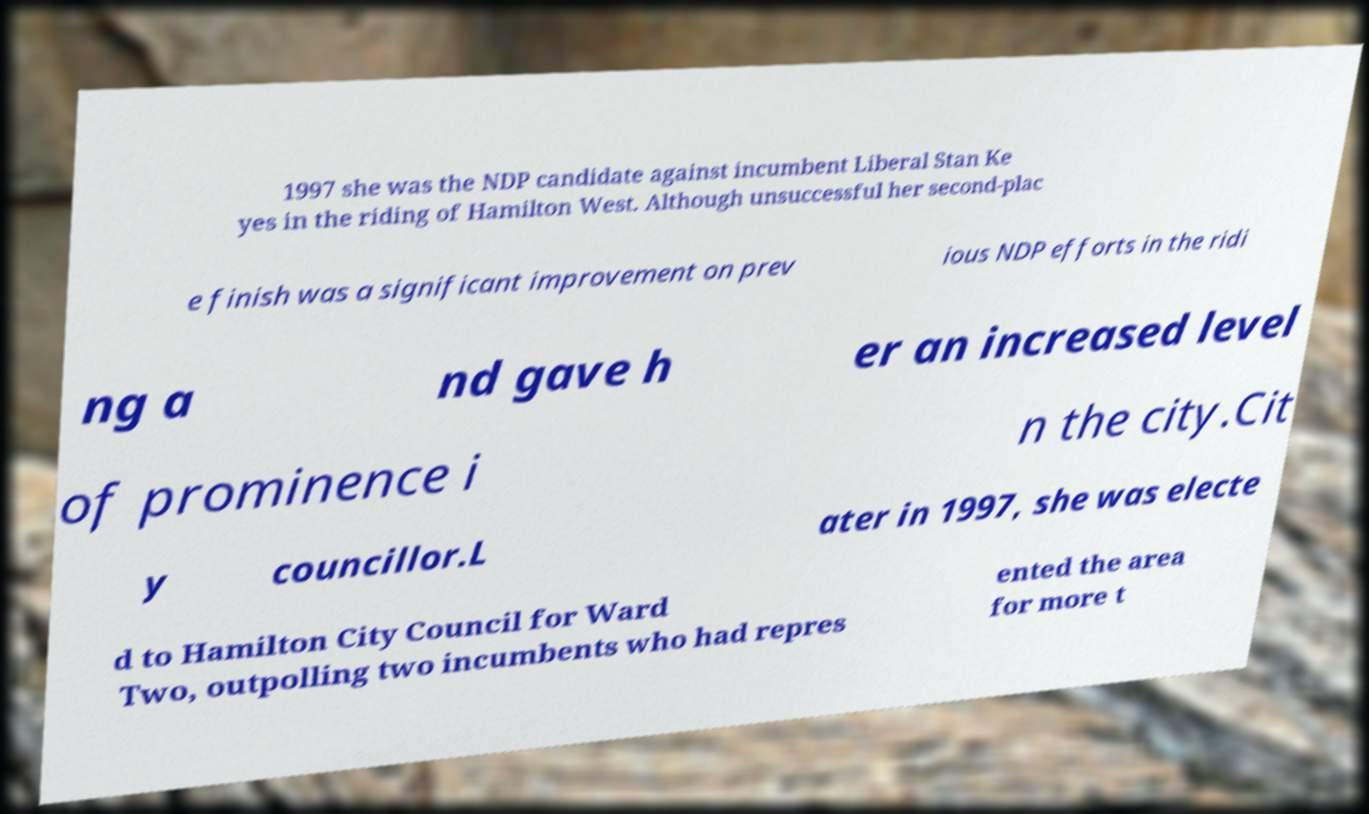Please read and relay the text visible in this image. What does it say? 1997 she was the NDP candidate against incumbent Liberal Stan Ke yes in the riding of Hamilton West. Although unsuccessful her second-plac e finish was a significant improvement on prev ious NDP efforts in the ridi ng a nd gave h er an increased level of prominence i n the city.Cit y councillor.L ater in 1997, she was electe d to Hamilton City Council for Ward Two, outpolling two incumbents who had repres ented the area for more t 